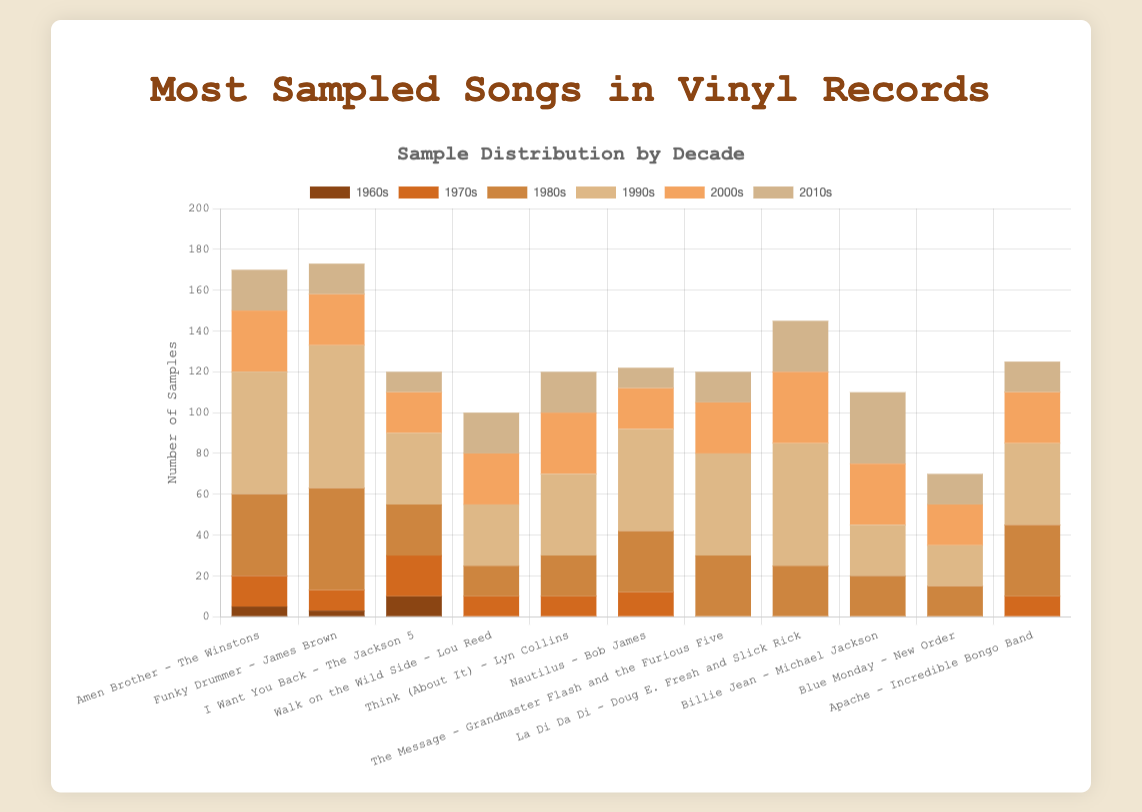What is the total number of samples for the song "Amen Brother" by The Winstons in the 1980s and 1990s combined? To find the total, sum the samples of "Amen Brother" in the 1980s (40) and the 1990s (60). 40 + 60 = 100.
Answer: 100 Which decade has the highest number of samples for the song "Funky Drummer" by James Brown? Look at the heights of the bars for "Funky Drummer" across all decades. The 1990s bar is the tallest, referring to its highest value (70).
Answer: 1990s Which song received more samples in the 2000s: "Think (About It)" by Lyn Collins or "Nautilus" by Bob James? Compare the heights of the bars for "Think (About It)" and "Nautilus" in the 2000s. "Think (About It)" has 30 samples whereas "Nautilus" has 20.
Answer: Think (About It) What is the genre of the song "La Di Da Di" by Doug E. Fresh and Slick Rick? The genre of a song can be found in the tooltip or label for "La Di Da Di" by Doug E. Fresh and Slick Rick. It is mentioned as Hip-Hop in the data.
Answer: Hip-Hop How many total samples did "Walk on the Wild Side" by Lou Reed gather in the 1990s and 2000s combined? Add the samples of "Walk on the Wild Side" in the 1990s (30) and the 2000s (25). 30 + 25 = 55.
Answer: 55 In the 2010s, which song has the most samples? Compare the heights of the bars for all songs in the 2010s. "Billie Jean" by Michael Jackson has the tallest bar in the 2010s with 35 samples.
Answer: Billie Jean Is the number of samples for "Amen Brother" more or less than "Funky Drummer" in the 1980s? Compare the bars for "Amen Brother" (40) and "Funky Drummer" (50) in the 1980s. "Amen Brother" has fewer samples than "Funky Drummer".
Answer: Less How many samples does "The Message" by Grandmaster Flash and the Furious Five have in total? Sum the samples for "The Message" across all decades: 1980s (30), 1990s (50), 2000s (25), 2010s (15). 30 + 50 + 25 + 15 = 120.
Answer: 120 Which two songs from different genres have the same number of samples in the 2000s? Compare the bar heights/numbers for different songs and genres in the 2000s. "I Want You Back" by the Jackson 5 (Soul) and "Blue Monday" by New Order (Electronic) both have 20 samples.
Answer: I Want You Back - Blue Monday 